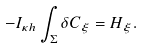Convert formula to latex. <formula><loc_0><loc_0><loc_500><loc_500>- I _ { \kappa h } \int _ { \Sigma } \delta C _ { \xi } = H _ { \xi } .</formula> 